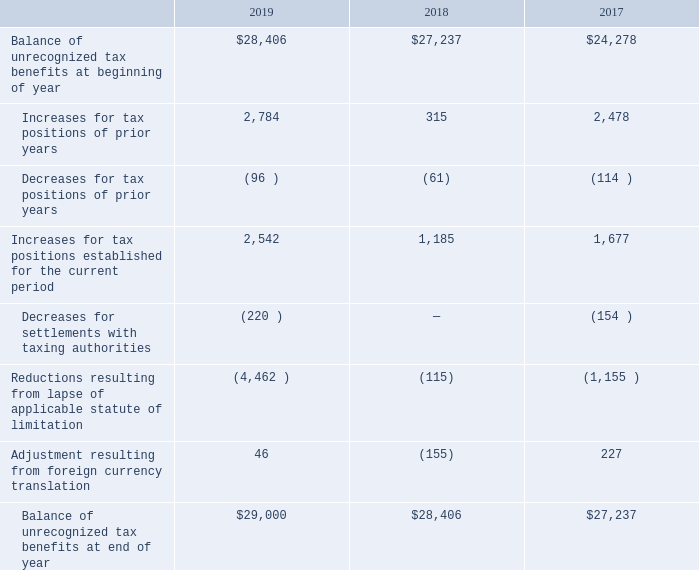The unrecognized tax benefit at December 31, 2019 and 2018, was $29.0 million and $28.4 million, respectively, of which $22.4 million and $22.6 million, respectively, are included in other noncurrent liabilities in the consolidated balance sheets. Of the total unrecognized tax benefit amounts at December 31, 2019 and 2018, $28.2 million and $27.5 million, respectively, represent the net unrecognized tax benefits that, if recognized, would favorably impact the effective income tax rate in the respective years.
A reconciliation of the beginning and ending amount of unrecognized tax benefits for the years ended December 31 is as follows (in thousands):
The Company files income tax returns in the U.S. federal jurisdiction, various state and local jurisdictions, and many foreign jurisdictions. The United States, Germany, India, Ireland, Luxembourg, Mexico, the United Kingdom, and Uruguay are the main taxing jurisdictions in which the Company operates. The years open for audit vary depending on the tax jurisdiction. In the United States, the Company’s tax returns for years following 2015 are open for audit. In the foreign jurisdictions, the tax returns open for audit generally vary by jurisdiction between 2003 and 2018.
The Company’s Indian income tax returns covering fiscal years 2003, 2005, 2010 through 2013, and 2016 are under audit by the Indian tax authority. Other foreign subsidiaries could face challenges from various foreign tax authorities. It is not certain that the local authorities will accept the Company’s tax positions. The Company believes its tax positions comply with applicable tax law and intends to vigorously defend its positions. However, differing positions on certain issues could be upheld by tax authorities, which could adversely affect the Company’s financial condition and results of operations.
The Company believes it is reasonably possible that the total amount of unrecognized tax benefits will decrease within the next 12 months by approximately $11.7 million due to the settlement of various audits and the expiration of statutes of limitations. The Company accrues interest related to uncertain tax positions in interest expense or interest income and recognizes penalties related to uncertain tax positions in other income or other expense. As of December 31, 2019 and 2018, $1.2 million is accrued for the payment of interest and penalties related to income tax liabilities. The aggregate amount of interest and penalties expense (benefit) recorded in the statements of operations for the years ended December 31, 2019, 2018, and 2017, is $0.2 million, $0.0 million, and $(0.8) million, respectively.
What was the balance of unrecognized tax benefits at the beginning of 2019?
Answer scale should be: thousand. $28,406. What was the balance of unrecognized tax benefits at the beginning of 2017?
Answer scale should be: thousand. $24,278. What was the increases for tax positions of prior years in 2019?
Answer scale should be: thousand. 2,784. What was the change in Balance of unrecognized tax benefits at beginning of year between 2017 and 2018?
Answer scale should be: thousand. $27,237-$24,278
Answer: 2959. What was the change in balance of unrecognized tax benefits at the end of the year between 2018 and 2019?
Answer scale should be: thousand. $29,000-$28,406
Answer: 594. What was the percentage change in increases for tax positions established for the current year between 2018 and 2019?
Answer scale should be: percent. (2,542-1,185)/1,185
Answer: 114.51. 